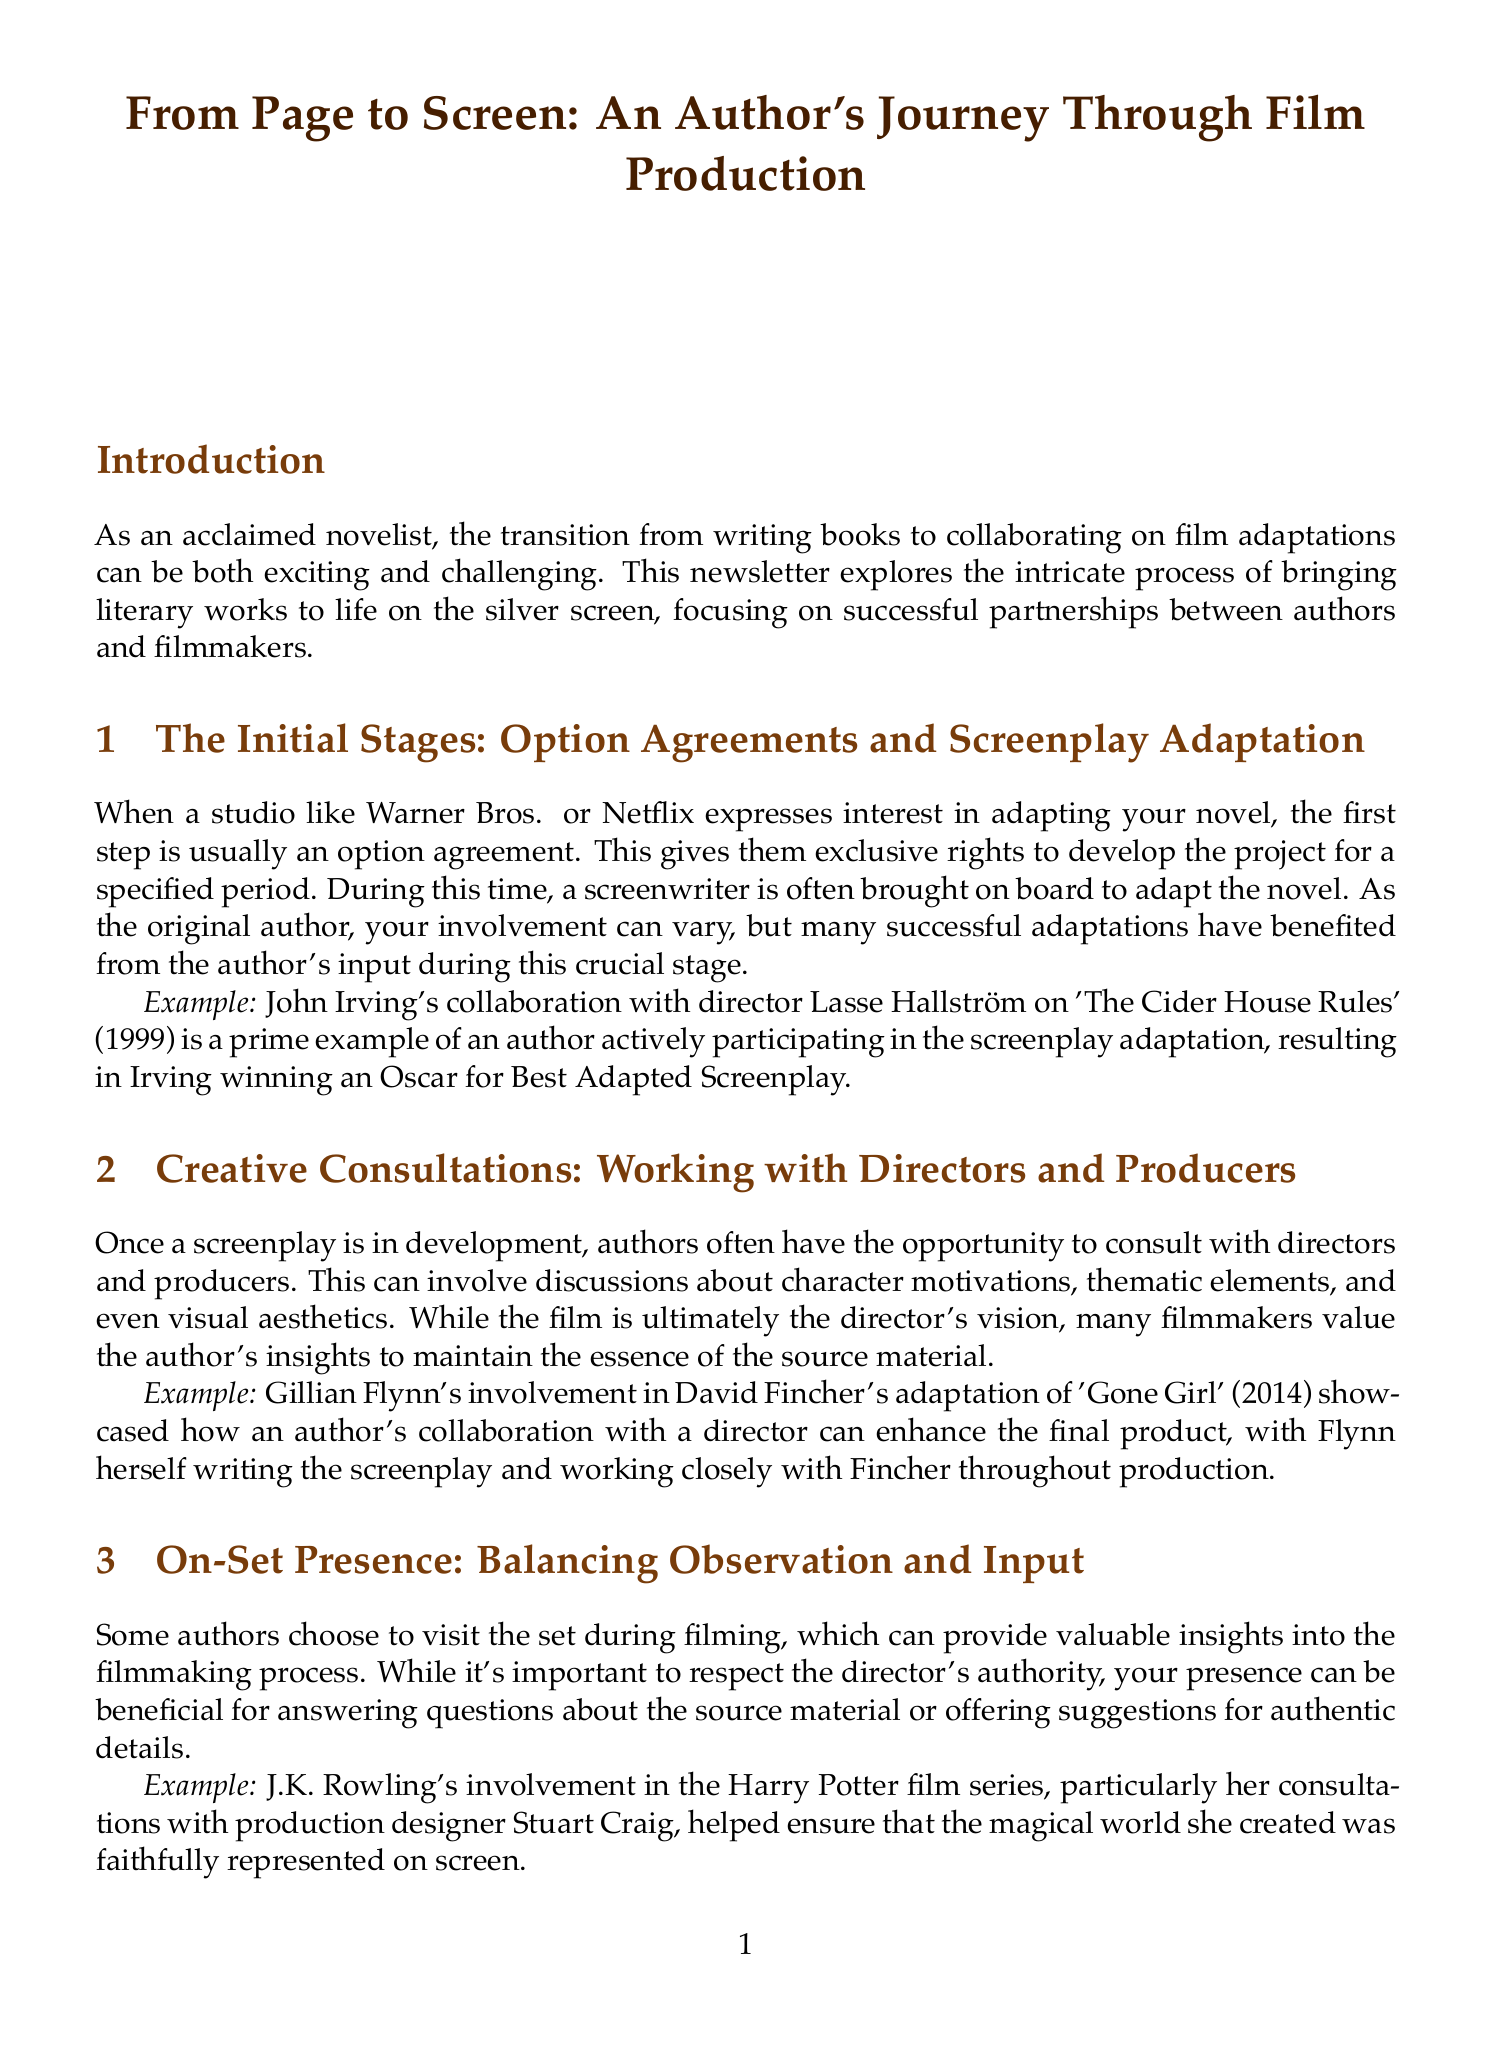What is the title of the newsletter? The title of the newsletter is stated at the beginning of the document.
Answer: From Page to Screen: An Author's Journey Through Film Production Who collaborated with Lasse Hallström on 'The Cider House Rules'? The document mentions a specific author who worked with the director Lasse Hallström on the adaptation.
Answer: John Irving In which year was 'Gone Girl' released? The release year of 'Gone Girl' is provided in the example section of the document.
Answer: 2014 What major film project did J.K. Rowling consult on? The document specifies a significant film series in which J.K. Rowling's involvement was notable.
Answer: Harry Potter What is one role authors may have in post-production? The document elaborates on the involvement of authors in a specific activity during post-production.
Answer: Marketing What does navigating creative differences entail? The document discusses a key concept in author-filmmaker relationships, emphasizing the importance of compromise.
Answer: Professionalism How can an author's presence on set be beneficial? The document explains the role of an author visiting a film set for a specific purpose.
Answer: Answering questions What did Anthony Burgess initially feel about 'A Clockwork Orange'? The document addresses the author’s initial stance regarding the adaptation of his work.
Answer: Skeptical What type of agreements initiate the film adaptation process? The document states the initial legal step taken when adapting a novel for film.
Answer: Option agreements 